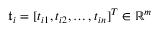<formula> <loc_0><loc_0><loc_500><loc_500>\mathfrak { t } _ { i } = [ t _ { i 1 } , t _ { i 2 } , \dots , t _ { i n } ] ^ { T } \in \mathbb { R } ^ { m }</formula> 